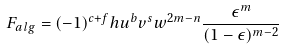Convert formula to latex. <formula><loc_0><loc_0><loc_500><loc_500>F _ { a l g } = ( - 1 ) ^ { c + f } h u ^ { b } v ^ { s } w ^ { 2 m - n } \frac { \epsilon ^ { m } } { ( 1 - \epsilon ) ^ { m - 2 } }</formula> 